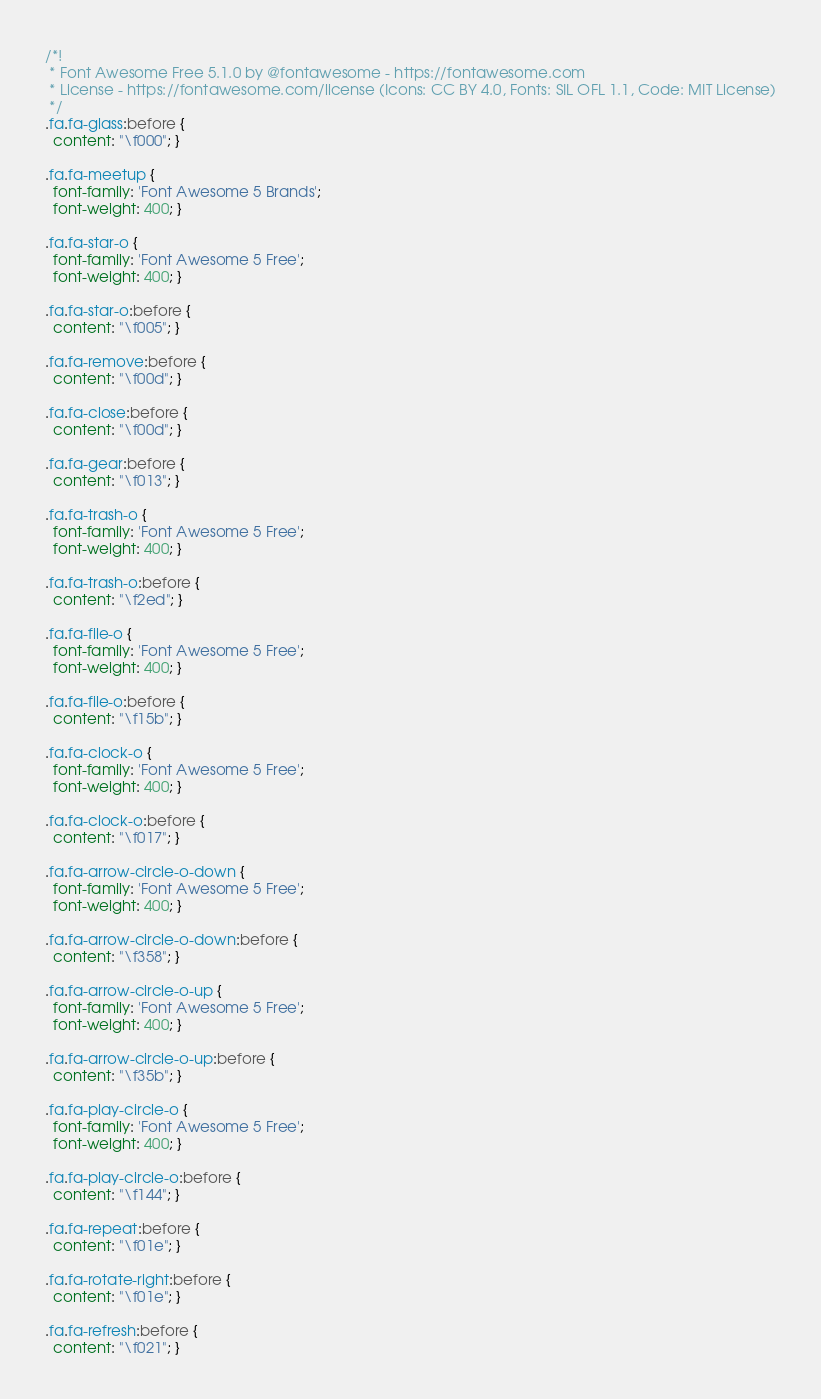Convert code to text. <code><loc_0><loc_0><loc_500><loc_500><_CSS_>/*!
 * Font Awesome Free 5.1.0 by @fontawesome - https://fontawesome.com
 * License - https://fontawesome.com/license (Icons: CC BY 4.0, Fonts: SIL OFL 1.1, Code: MIT License)
 */
.fa.fa-glass:before {
  content: "\f000"; }

.fa.fa-meetup {
  font-family: 'Font Awesome 5 Brands';
  font-weight: 400; }

.fa.fa-star-o {
  font-family: 'Font Awesome 5 Free';
  font-weight: 400; }

.fa.fa-star-o:before {
  content: "\f005"; }

.fa.fa-remove:before {
  content: "\f00d"; }

.fa.fa-close:before {
  content: "\f00d"; }

.fa.fa-gear:before {
  content: "\f013"; }

.fa.fa-trash-o {
  font-family: 'Font Awesome 5 Free';
  font-weight: 400; }

.fa.fa-trash-o:before {
  content: "\f2ed"; }

.fa.fa-file-o {
  font-family: 'Font Awesome 5 Free';
  font-weight: 400; }

.fa.fa-file-o:before {
  content: "\f15b"; }

.fa.fa-clock-o {
  font-family: 'Font Awesome 5 Free';
  font-weight: 400; }

.fa.fa-clock-o:before {
  content: "\f017"; }

.fa.fa-arrow-circle-o-down {
  font-family: 'Font Awesome 5 Free';
  font-weight: 400; }

.fa.fa-arrow-circle-o-down:before {
  content: "\f358"; }

.fa.fa-arrow-circle-o-up {
  font-family: 'Font Awesome 5 Free';
  font-weight: 400; }

.fa.fa-arrow-circle-o-up:before {
  content: "\f35b"; }

.fa.fa-play-circle-o {
  font-family: 'Font Awesome 5 Free';
  font-weight: 400; }

.fa.fa-play-circle-o:before {
  content: "\f144"; }

.fa.fa-repeat:before {
  content: "\f01e"; }

.fa.fa-rotate-right:before {
  content: "\f01e"; }

.fa.fa-refresh:before {
  content: "\f021"; }</code> 